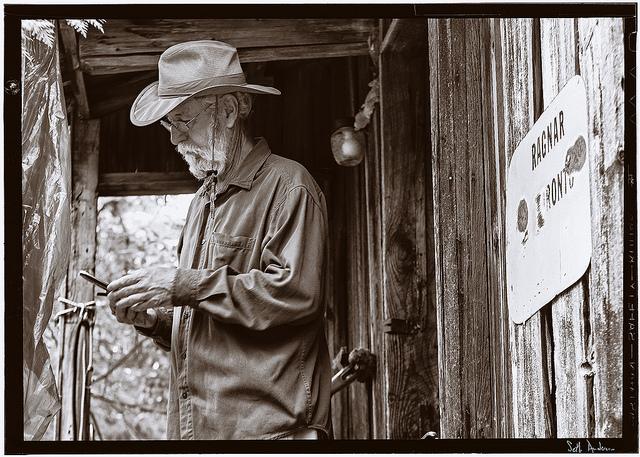What is the man looking at?
Answer briefly. Phone. What is the man doing?
Be succinct. Texting. Is this man a palace guard?
Write a very short answer. No. What is the man wearing on his head?
Be succinct. Hat. What is this person holding?
Give a very brief answer. Phone. 